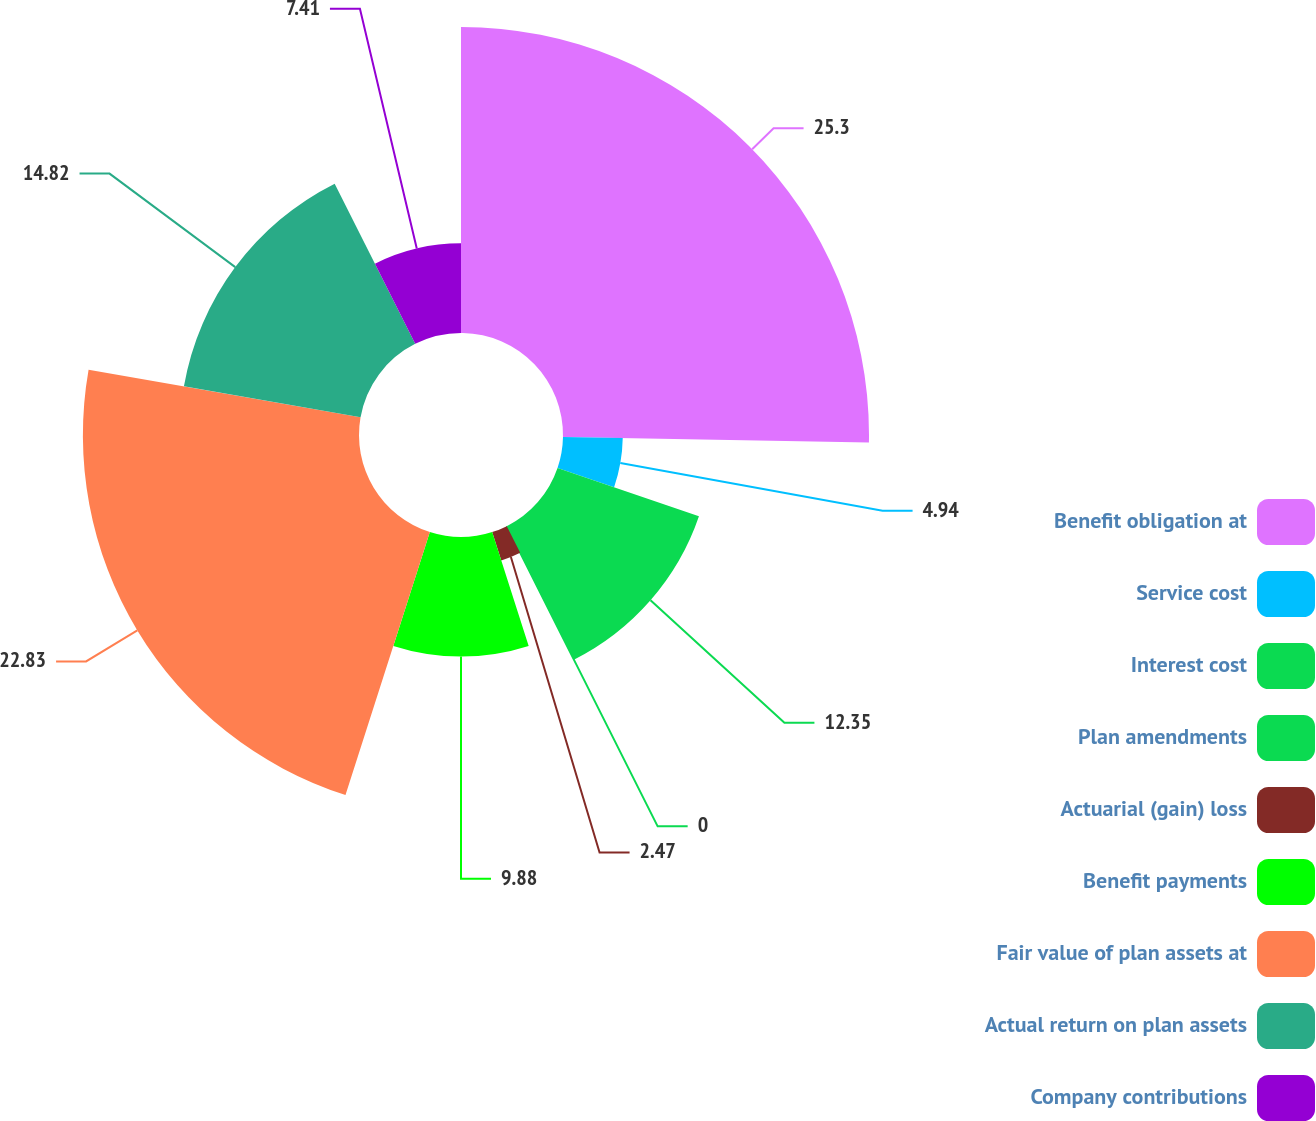<chart> <loc_0><loc_0><loc_500><loc_500><pie_chart><fcel>Benefit obligation at<fcel>Service cost<fcel>Interest cost<fcel>Plan amendments<fcel>Actuarial (gain) loss<fcel>Benefit payments<fcel>Fair value of plan assets at<fcel>Actual return on plan assets<fcel>Company contributions<nl><fcel>25.29%<fcel>4.94%<fcel>12.35%<fcel>0.0%<fcel>2.47%<fcel>9.88%<fcel>22.82%<fcel>14.82%<fcel>7.41%<nl></chart> 